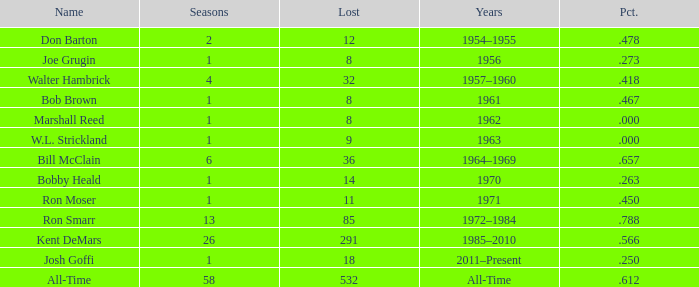Which Seasons has a Name of joe grugin, and a Lost larger than 8? 0.0. 